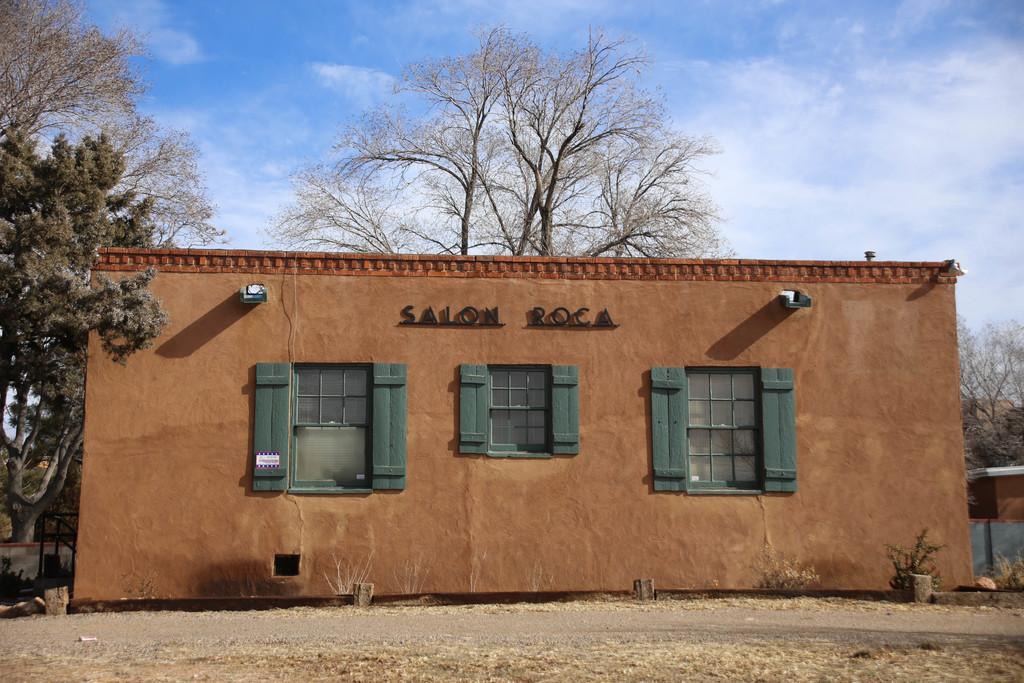Can you describe this image briefly? In the center of the image we can see a building and windows. In the background there are trees and sky. 